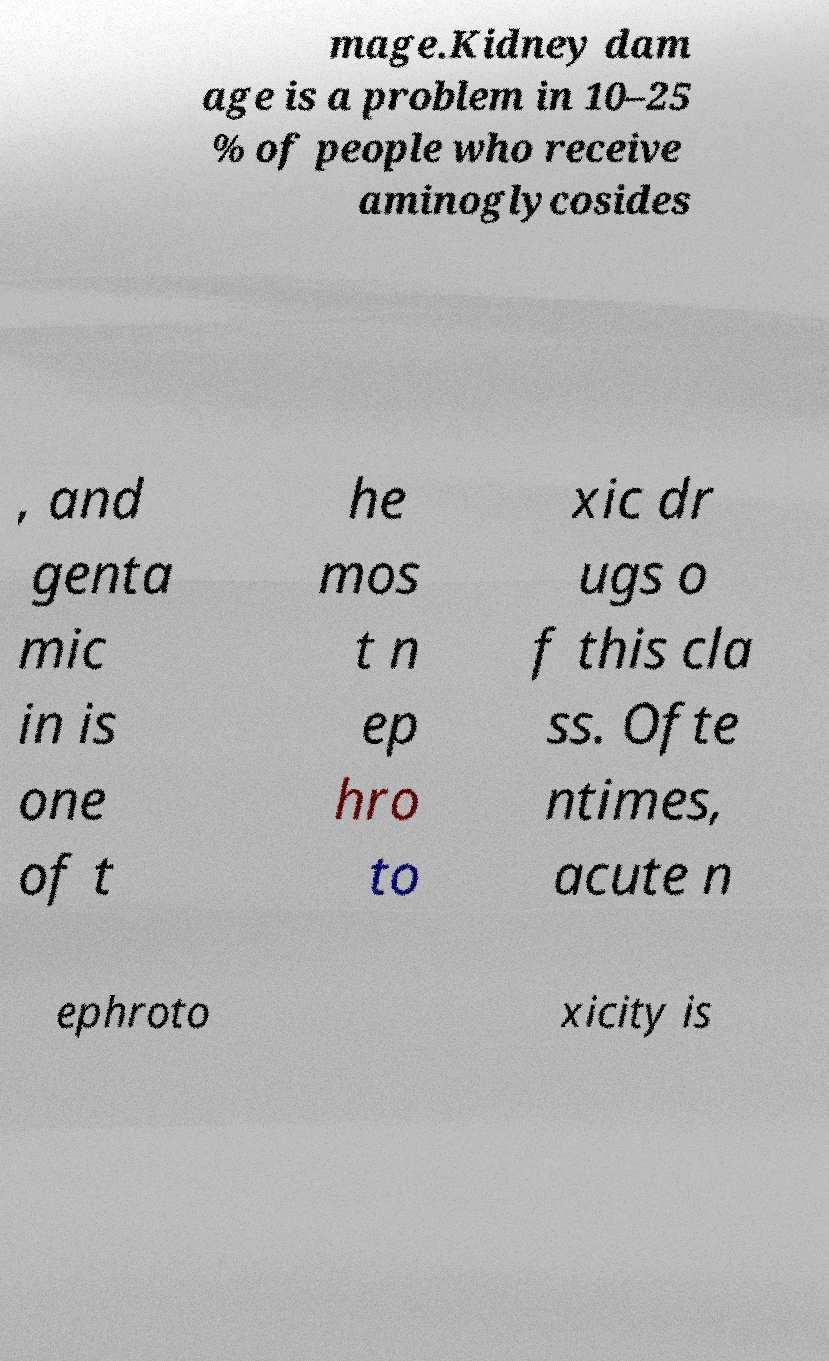Can you read and provide the text displayed in the image?This photo seems to have some interesting text. Can you extract and type it out for me? mage.Kidney dam age is a problem in 10–25 % of people who receive aminoglycosides , and genta mic in is one of t he mos t n ep hro to xic dr ugs o f this cla ss. Ofte ntimes, acute n ephroto xicity is 